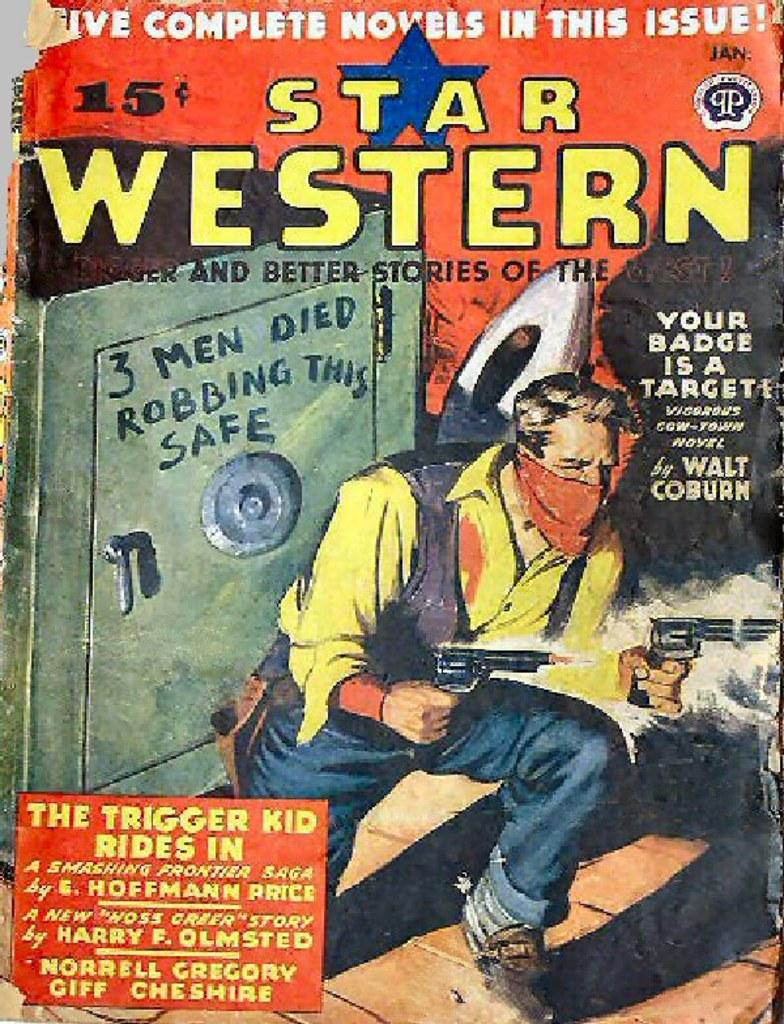<image>
Describe the image concisely. Cover for a book titled Star Western showing a man holding a gun. 